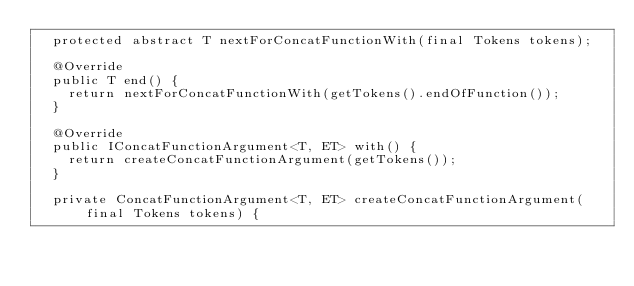<code> <loc_0><loc_0><loc_500><loc_500><_Java_>	protected abstract T nextForConcatFunctionWith(final Tokens tokens);

	@Override
	public T end() {
		return nextForConcatFunctionWith(getTokens().endOfFunction());
	}

	@Override
	public IConcatFunctionArgument<T, ET> with() {
		return createConcatFunctionArgument(getTokens());
	}

	private ConcatFunctionArgument<T, ET> createConcatFunctionArgument(final Tokens tokens) {</code> 